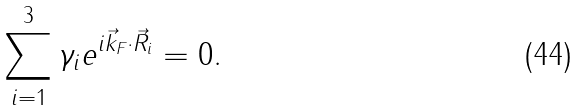<formula> <loc_0><loc_0><loc_500><loc_500>\sum _ { i = 1 } ^ { 3 } \gamma _ { i } e ^ { i \vec { k } _ { F } \cdot \vec { R } _ { i } } = 0 .</formula> 